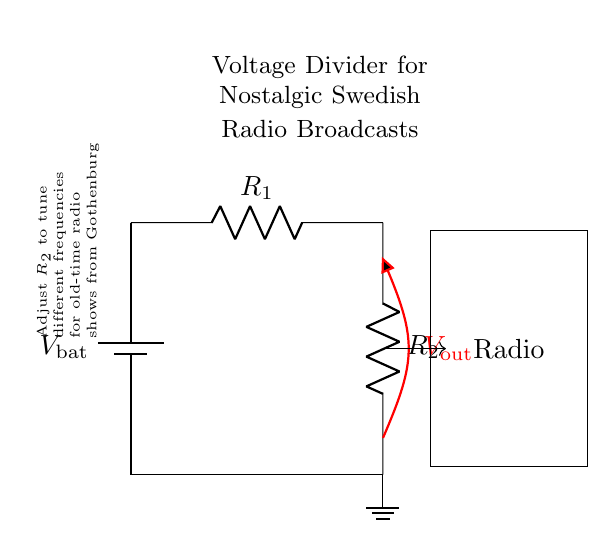What does the battery represent in the circuit? The battery represents the power supply, denoted as V_bat, which provides the necessary voltage for the circuit to operate.
Answer: Power supply What is the purpose of resistor R1? Resistor R1 is part of the voltage divider, working with R2 to divide the voltage coming from the battery to a lower value for the radio.
Answer: Voltage division Which component is responsible for tuning the radio? Resistor R2 is responsible for tuning the radio by adjusting the voltage output, affecting the frequency received by the radio.
Answer: R2 What is the output voltage represented as? The output voltage is represented as V_out, indicating the voltage that will be supplied to the radio from the divider.
Answer: V_out How are the resistors connected in this circuit? The resistors R1 and R2 are connected in series, meaning the output voltage is taken across R2 after R1.
Answer: Series What adjustment can be made to change the radio station? Adjusting the value of resistor R2 changes the output voltage, which allows for tuning into different radio frequencies.
Answer: Adjusting R2 What is the function of the ground in this circuit? The ground serves as a reference point for the circuit, completing the electrical connection and allowing the current to return to the battery.
Answer: Reference point 